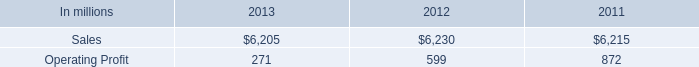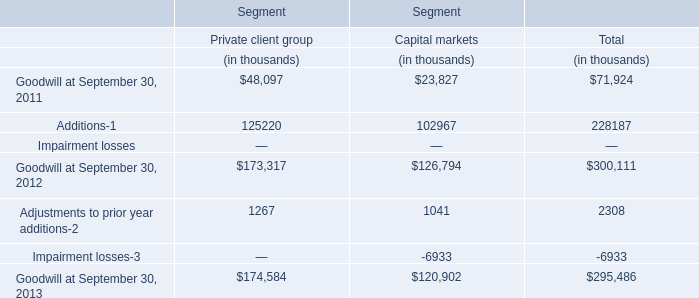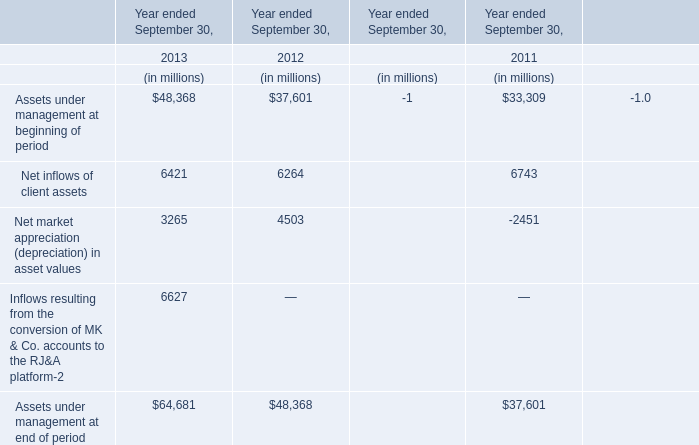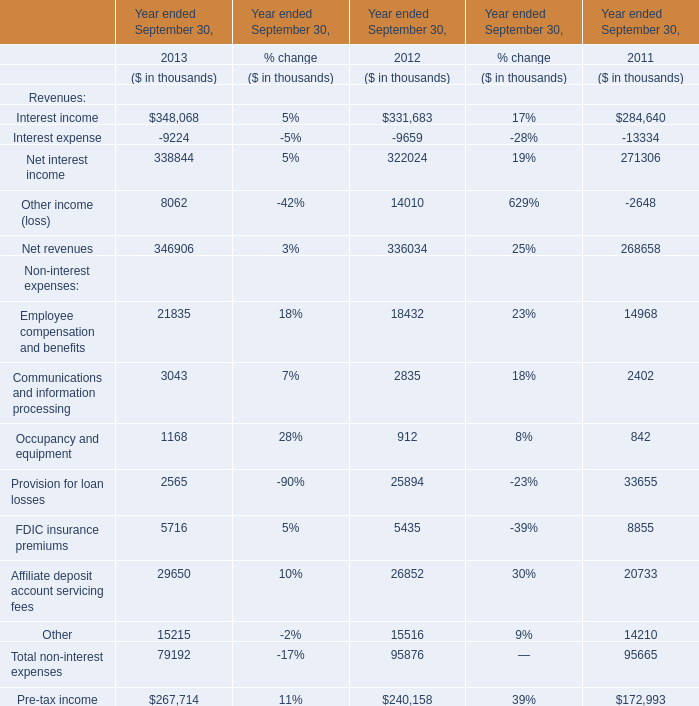Which Revenues continue to rise each year from 2011 to 2013? 
Answer: Net interest income Net revenues. 